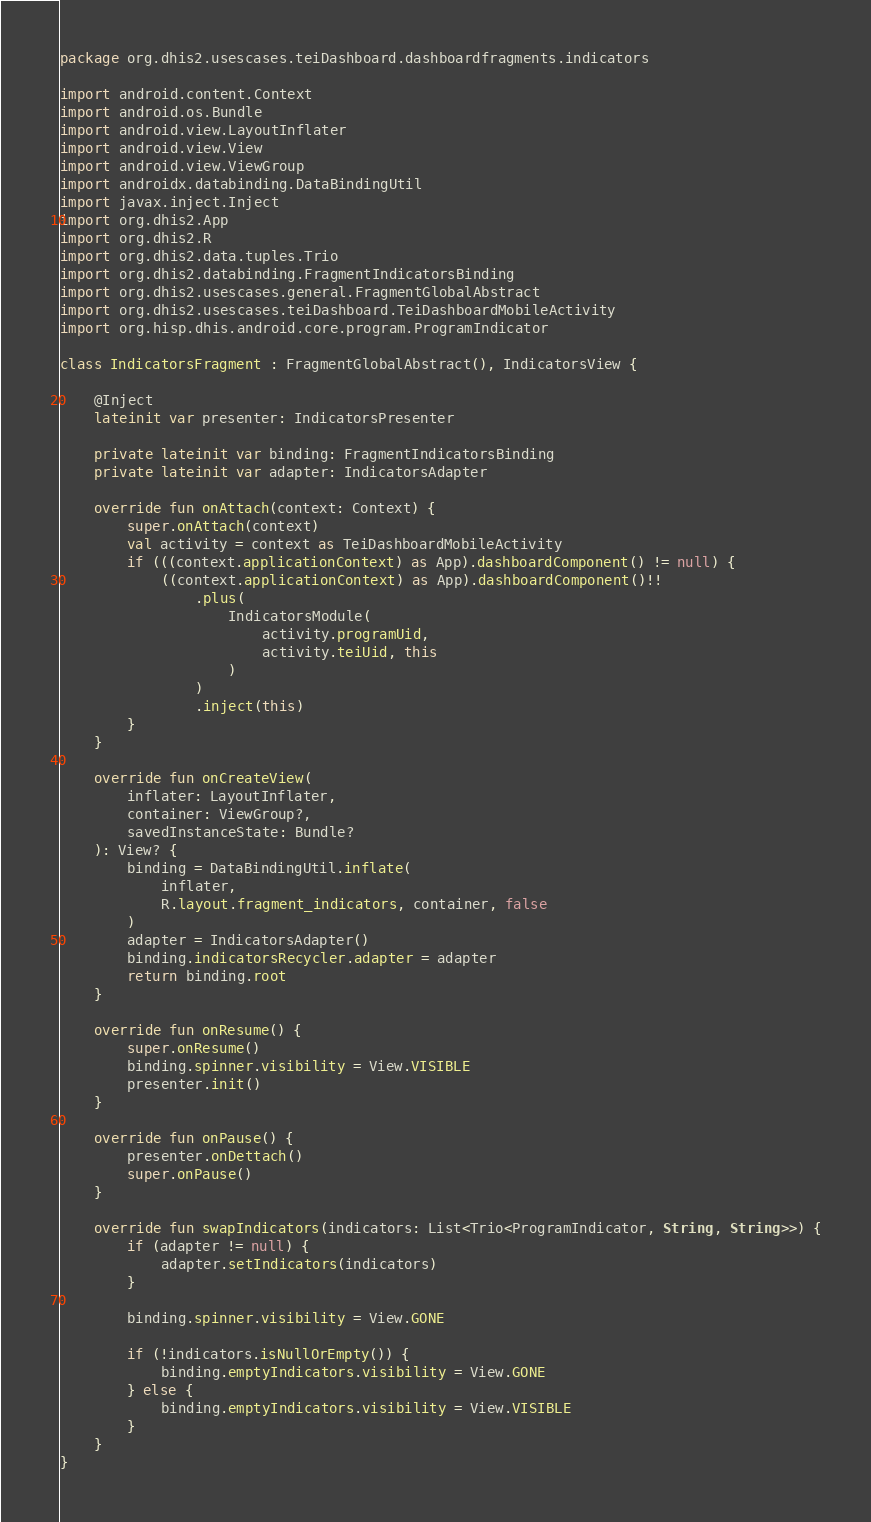<code> <loc_0><loc_0><loc_500><loc_500><_Kotlin_>package org.dhis2.usescases.teiDashboard.dashboardfragments.indicators

import android.content.Context
import android.os.Bundle
import android.view.LayoutInflater
import android.view.View
import android.view.ViewGroup
import androidx.databinding.DataBindingUtil
import javax.inject.Inject
import org.dhis2.App
import org.dhis2.R
import org.dhis2.data.tuples.Trio
import org.dhis2.databinding.FragmentIndicatorsBinding
import org.dhis2.usescases.general.FragmentGlobalAbstract
import org.dhis2.usescases.teiDashboard.TeiDashboardMobileActivity
import org.hisp.dhis.android.core.program.ProgramIndicator

class IndicatorsFragment : FragmentGlobalAbstract(), IndicatorsView {

    @Inject
    lateinit var presenter: IndicatorsPresenter

    private lateinit var binding: FragmentIndicatorsBinding
    private lateinit var adapter: IndicatorsAdapter

    override fun onAttach(context: Context) {
        super.onAttach(context)
        val activity = context as TeiDashboardMobileActivity
        if (((context.applicationContext) as App).dashboardComponent() != null) {
            ((context.applicationContext) as App).dashboardComponent()!!
                .plus(
                    IndicatorsModule(
                        activity.programUid,
                        activity.teiUid, this
                    )
                )
                .inject(this)
        }
    }

    override fun onCreateView(
        inflater: LayoutInflater,
        container: ViewGroup?,
        savedInstanceState: Bundle?
    ): View? {
        binding = DataBindingUtil.inflate(
            inflater,
            R.layout.fragment_indicators, container, false
        )
        adapter = IndicatorsAdapter()
        binding.indicatorsRecycler.adapter = adapter
        return binding.root
    }

    override fun onResume() {
        super.onResume()
        binding.spinner.visibility = View.VISIBLE
        presenter.init()
    }

    override fun onPause() {
        presenter.onDettach()
        super.onPause()
    }

    override fun swapIndicators(indicators: List<Trio<ProgramIndicator, String, String>>) {
        if (adapter != null) {
            adapter.setIndicators(indicators)
        }

        binding.spinner.visibility = View.GONE

        if (!indicators.isNullOrEmpty()) {
            binding.emptyIndicators.visibility = View.GONE
        } else {
            binding.emptyIndicators.visibility = View.VISIBLE
        }
    }
}
</code> 